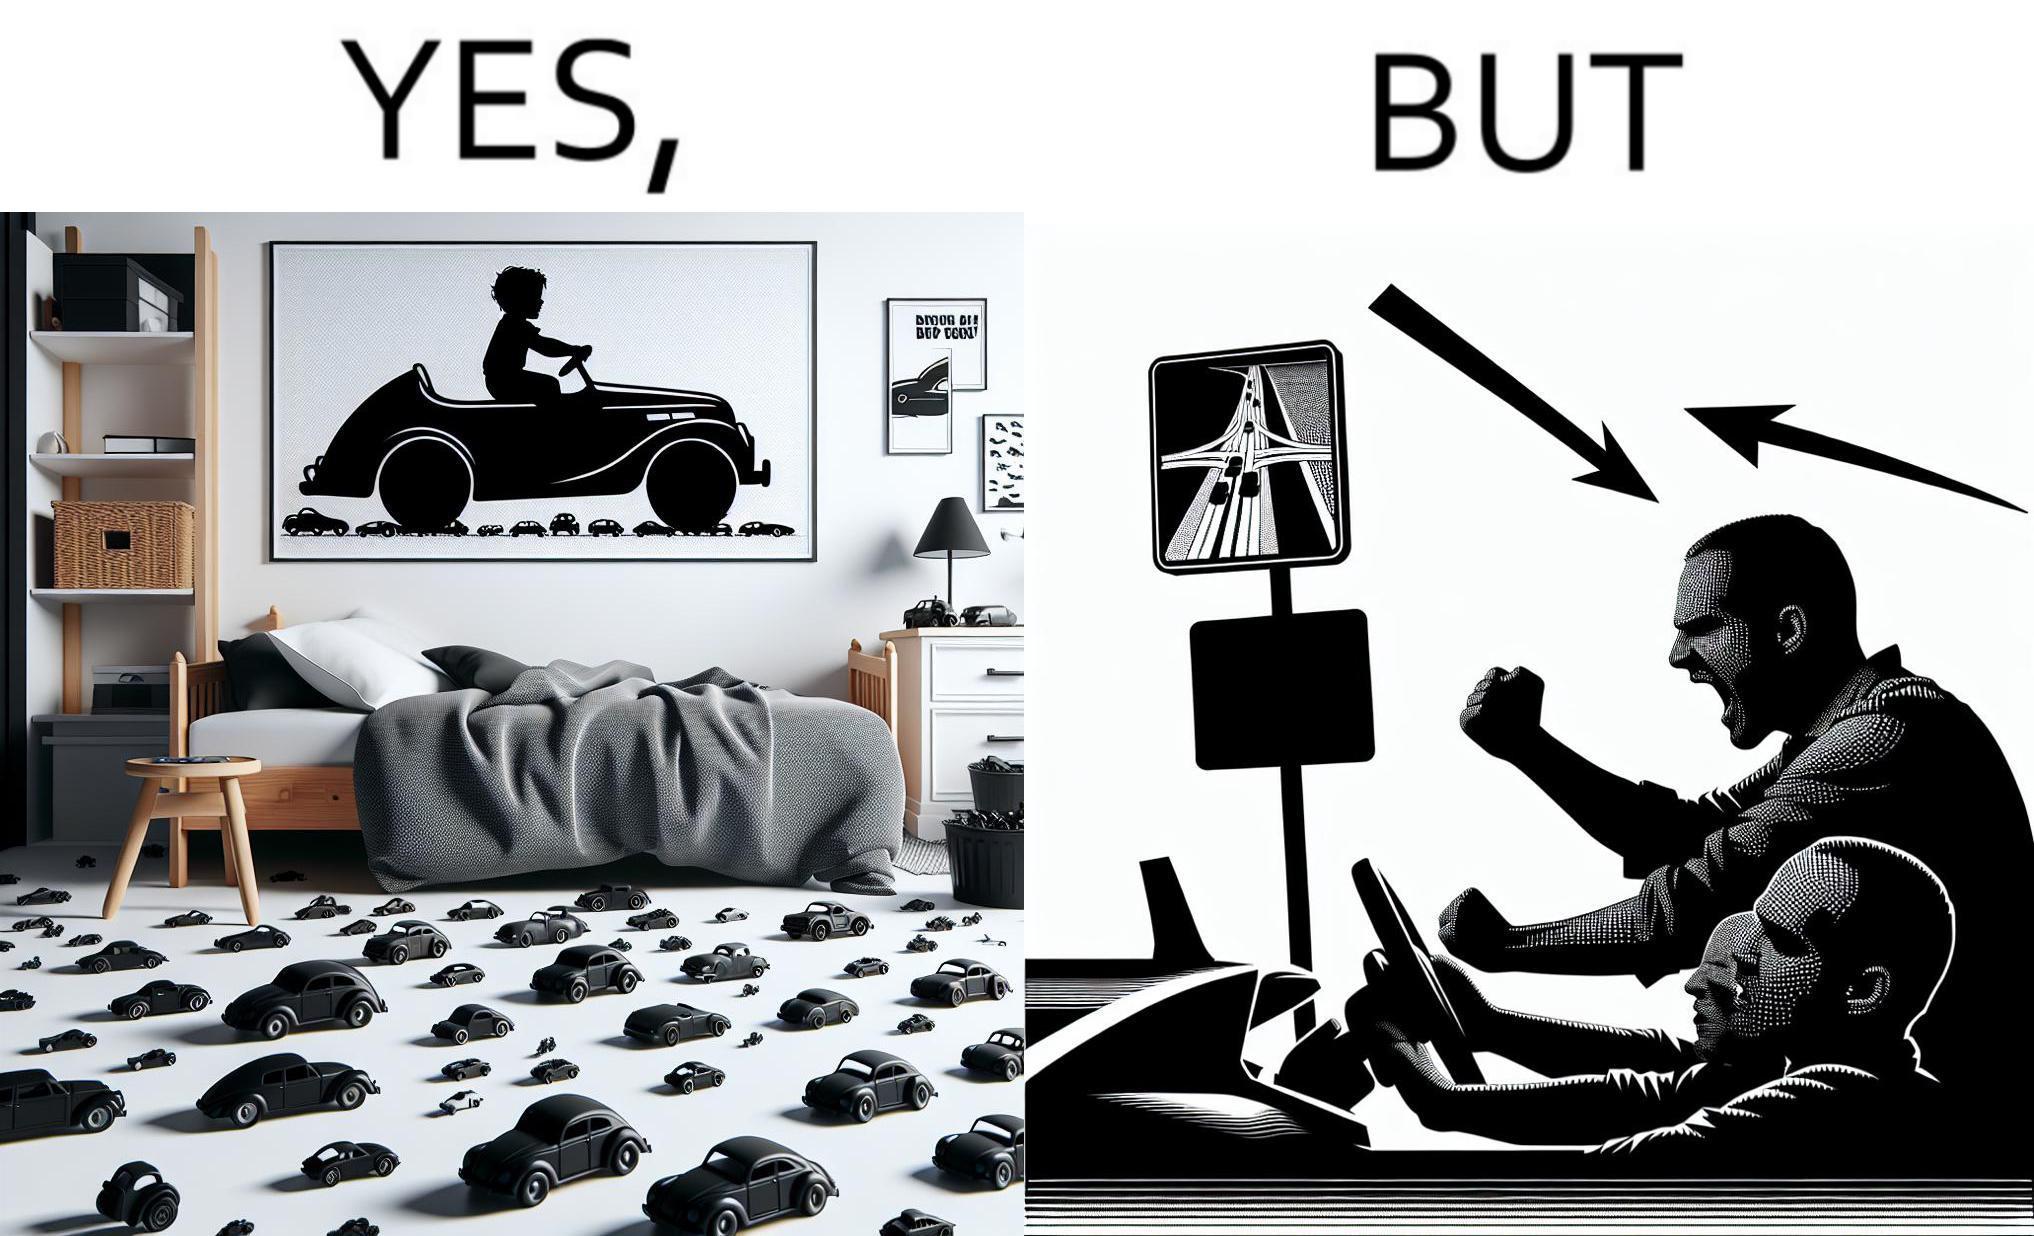Why is this image considered satirical? The image is funny beaucse while the person as a child enjoyed being around cars, had various small toy cars and even rode a bigger toy car, as as grown up he does not enjoy being in a car during a traffic jam while he is driving . 